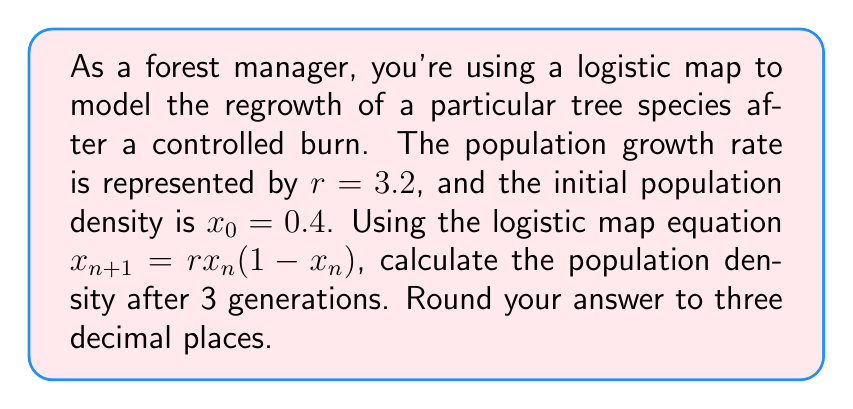Can you answer this question? To solve this problem, we'll use the logistic map equation iteratively for three generations:

1) First generation ($n = 0$ to $n = 1$):
   $x_1 = rx_0(1-x_0)$
   $x_1 = 3.2 * 0.4 * (1-0.4)$
   $x_1 = 3.2 * 0.4 * 0.6 = 0.768$

2) Second generation ($n = 1$ to $n = 2$):
   $x_2 = rx_1(1-x_1)$
   $x_2 = 3.2 * 0.768 * (1-0.768)$
   $x_2 = 3.2 * 0.768 * 0.232 = 0.570163$

3) Third generation ($n = 2$ to $n = 3$):
   $x_3 = rx_2(1-x_2)$
   $x_3 = 3.2 * 0.570163 * (1-0.570163)$
   $x_3 = 3.2 * 0.570163 * 0.429837 = 0.784841$

Rounding to three decimal places: 0.785
Answer: 0.785 